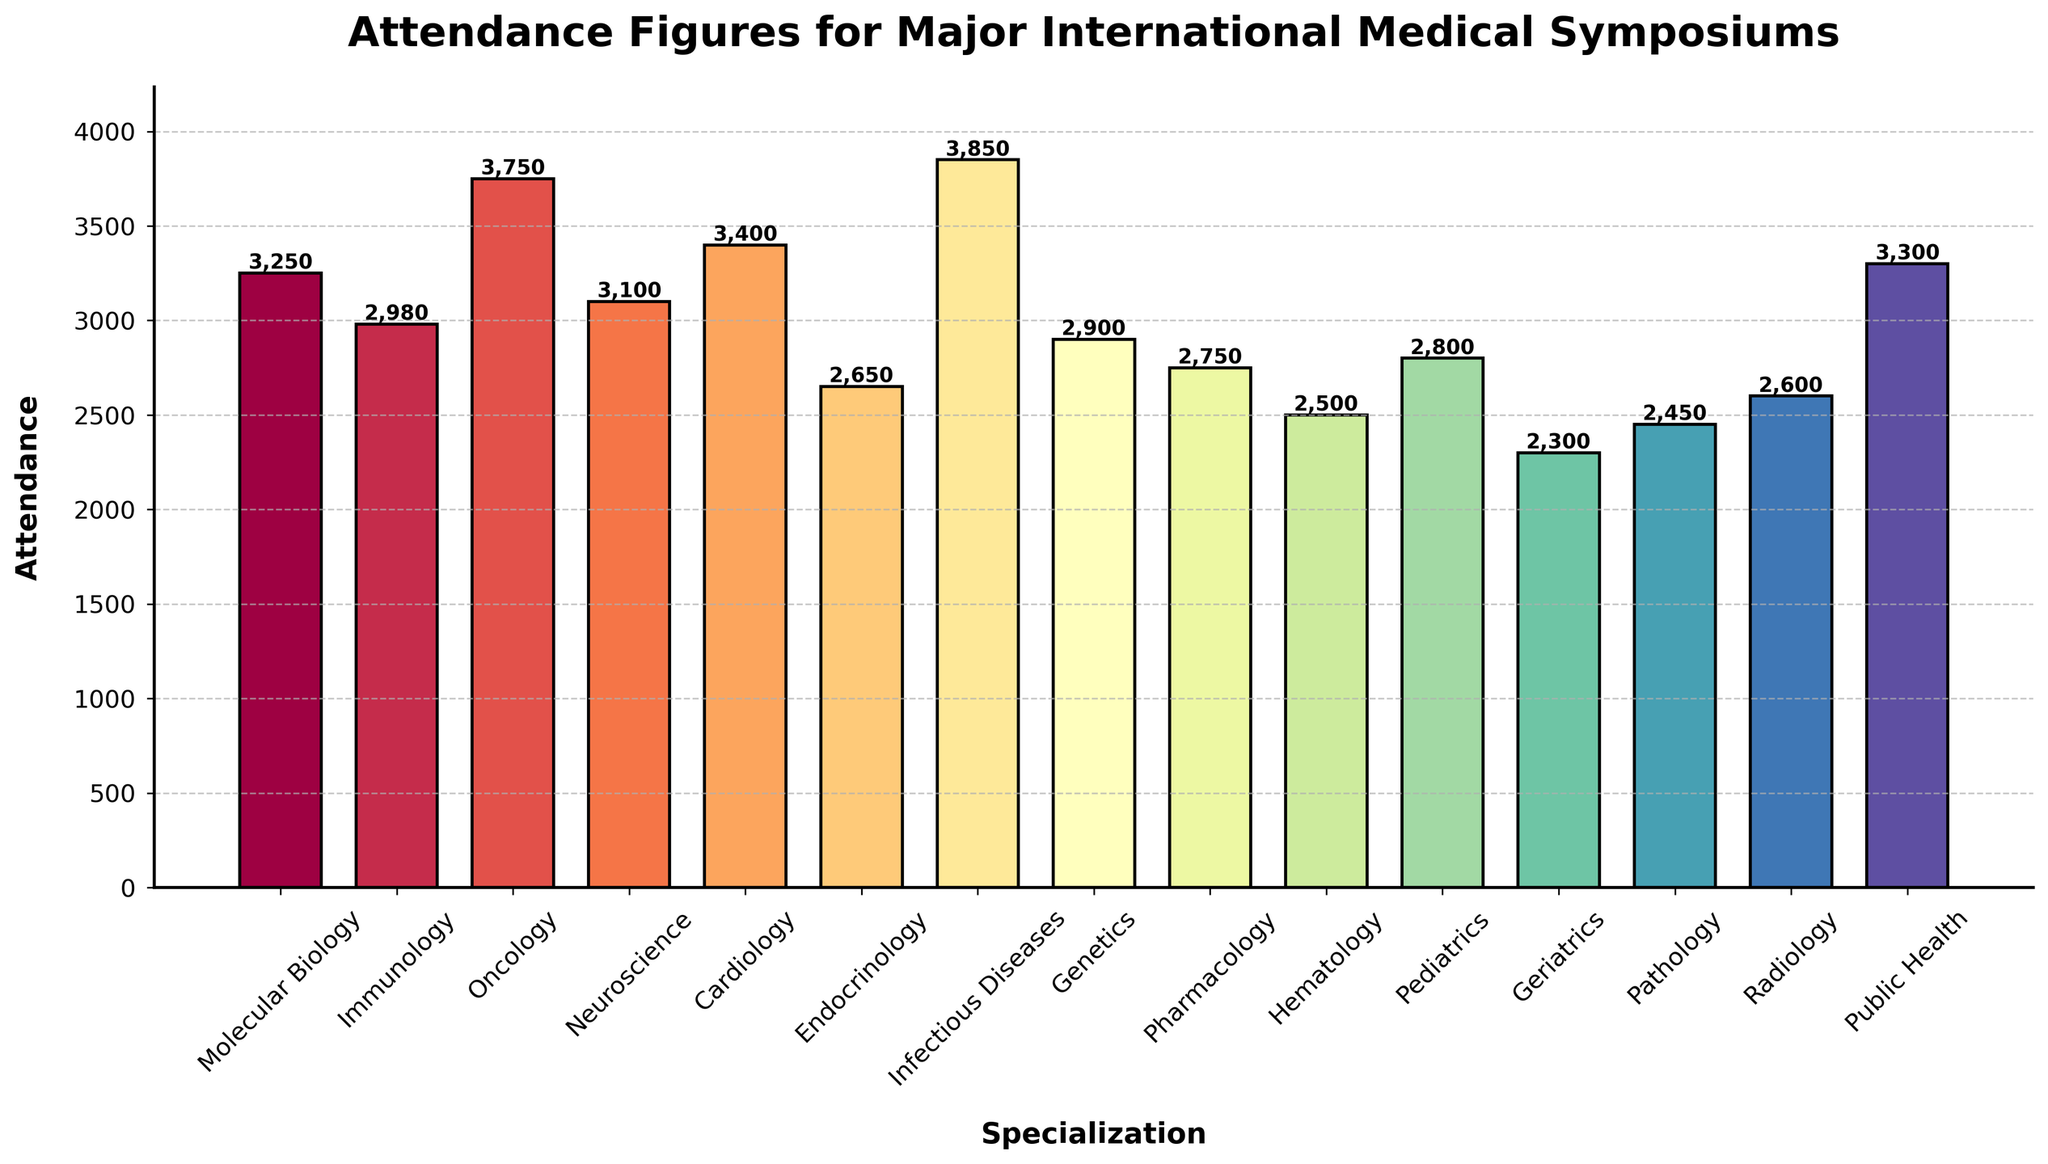Which specialization has the highest attendance? We observe the height of the bars and see that the bar for Infectious Diseases is the tallest, indicating the highest attendance.
Answer: Infectious Diseases Which specialization has the lowest attendance? By examining the heights of the bars, we see that the Geriatrics bar is the shortest, representing the lowest attendance.
Answer: Geriatrics Which two specializations have the closest attendance figures? Looking at the bar heights, Molecular Biology (3250) and Public Health (3300) have the closest figures with a difference of only 50 attendees.
Answer: Molecular Biology and Public Health What is the combined attendance of Oncology and Cardiology symposiums? The attendance for Oncology is 3750 and for Cardiology is 3400. Adding these together gives 3750 + 3400 = 7150.
Answer: 7150 How much higher is the attendance for Infectious Diseases compared to Hematology? The attendance for Infectious Diseases is 3850 and for Hematology is 2500. The difference is 3850 - 2500 = 1350.
Answer: 1350 Which specialization has the median attendance figure? To find the median, list all attendances in ascending order and find the middle value. The sorted attendances are: 2300, 2450, 2500, 2600, 2650, 2750, 2800, 2900, 2980, 3100, 3250, 3300, 3400, 3750, 3850. The median is the 8th value, which is 2900 for Genetics.
Answer: Genetics Is the attendance for Neuroscience higher or lower than the average attendance? First, calculate the average attendance by summing all values and dividing by the number of specializations: (3250 + 2980 + 3750 + 3100 + 3400 + 2650 + 3850 + 2900 + 2750 + 2500 + 2800 + 2300 + 2450 + 2600 + 3300) / 15 = 3027. Neuroscience's attendance is 3100, which is higher than the average.
Answer: Higher Which specializations have attendance figures greater than 3000? We look at each bar and identify the ones taller than the 3000 mark. These specializations are Molecular Biology, Oncology, Neuroscience, Cardiology, Infectious Diseases, and Public Health.
Answer: Molecular Biology, Oncology, Neuroscience, Cardiology, Infectious Diseases, Public Health What is the range of attendance figures for all the specializations? The range is calculated by subtracting the smallest attendance from the largest. The smallest is 2300 (Geriatrics) and the largest is 3850 (Infectious Diseases). Range = 3850 - 2300 = 1550.
Answer: 1550 What is the difference in attendance between the highest and the median figures? The highest attendance is for Infectious Diseases at 3850 and the median attendance is for Genetics at 2900. The difference is 3850 - 2900 = 950.
Answer: 950 